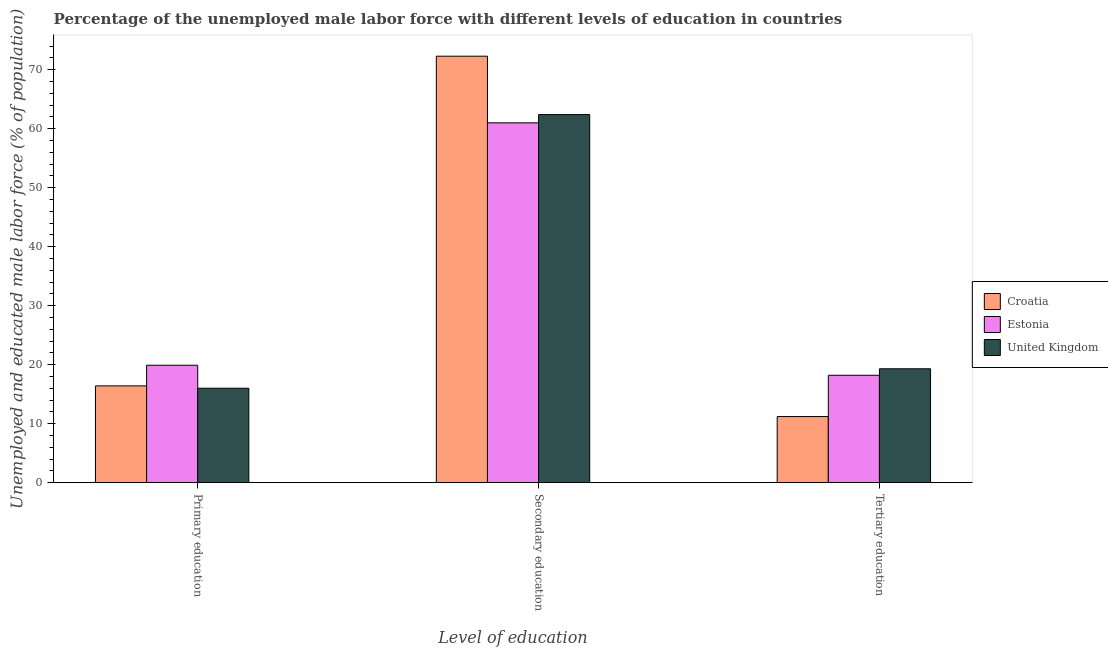How many different coloured bars are there?
Your response must be concise. 3. How many groups of bars are there?
Provide a short and direct response. 3. Are the number of bars per tick equal to the number of legend labels?
Ensure brevity in your answer.  Yes. Are the number of bars on each tick of the X-axis equal?
Give a very brief answer. Yes. How many bars are there on the 2nd tick from the left?
Ensure brevity in your answer.  3. How many bars are there on the 2nd tick from the right?
Keep it short and to the point. 3. What is the label of the 1st group of bars from the left?
Your answer should be compact. Primary education. What is the percentage of male labor force who received tertiary education in Croatia?
Your answer should be compact. 11.2. Across all countries, what is the maximum percentage of male labor force who received secondary education?
Provide a succinct answer. 72.3. In which country was the percentage of male labor force who received tertiary education maximum?
Your answer should be very brief. United Kingdom. In which country was the percentage of male labor force who received tertiary education minimum?
Make the answer very short. Croatia. What is the total percentage of male labor force who received primary education in the graph?
Provide a succinct answer. 52.3. What is the difference between the percentage of male labor force who received primary education in United Kingdom and that in Croatia?
Give a very brief answer. -0.4. What is the difference between the percentage of male labor force who received primary education in United Kingdom and the percentage of male labor force who received secondary education in Croatia?
Your response must be concise. -56.3. What is the average percentage of male labor force who received primary education per country?
Your answer should be compact. 17.43. What is the difference between the percentage of male labor force who received secondary education and percentage of male labor force who received tertiary education in Croatia?
Provide a short and direct response. 61.1. What is the ratio of the percentage of male labor force who received secondary education in Estonia to that in United Kingdom?
Give a very brief answer. 0.98. Is the percentage of male labor force who received secondary education in Estonia less than that in Croatia?
Provide a succinct answer. Yes. Is the difference between the percentage of male labor force who received primary education in Croatia and United Kingdom greater than the difference between the percentage of male labor force who received secondary education in Croatia and United Kingdom?
Keep it short and to the point. No. What is the difference between the highest and the second highest percentage of male labor force who received tertiary education?
Provide a succinct answer. 1.1. What is the difference between the highest and the lowest percentage of male labor force who received primary education?
Give a very brief answer. 3.9. In how many countries, is the percentage of male labor force who received secondary education greater than the average percentage of male labor force who received secondary education taken over all countries?
Keep it short and to the point. 1. What does the 2nd bar from the right in Primary education represents?
Make the answer very short. Estonia. Are all the bars in the graph horizontal?
Your response must be concise. No. How many countries are there in the graph?
Offer a very short reply. 3. What is the difference between two consecutive major ticks on the Y-axis?
Give a very brief answer. 10. Does the graph contain any zero values?
Your response must be concise. No. Does the graph contain grids?
Offer a very short reply. No. Where does the legend appear in the graph?
Give a very brief answer. Center right. How are the legend labels stacked?
Make the answer very short. Vertical. What is the title of the graph?
Give a very brief answer. Percentage of the unemployed male labor force with different levels of education in countries. What is the label or title of the X-axis?
Make the answer very short. Level of education. What is the label or title of the Y-axis?
Make the answer very short. Unemployed and educated male labor force (% of population). What is the Unemployed and educated male labor force (% of population) in Croatia in Primary education?
Provide a short and direct response. 16.4. What is the Unemployed and educated male labor force (% of population) of Estonia in Primary education?
Your answer should be very brief. 19.9. What is the Unemployed and educated male labor force (% of population) of United Kingdom in Primary education?
Your response must be concise. 16. What is the Unemployed and educated male labor force (% of population) in Croatia in Secondary education?
Ensure brevity in your answer.  72.3. What is the Unemployed and educated male labor force (% of population) in United Kingdom in Secondary education?
Ensure brevity in your answer.  62.4. What is the Unemployed and educated male labor force (% of population) in Croatia in Tertiary education?
Make the answer very short. 11.2. What is the Unemployed and educated male labor force (% of population) of Estonia in Tertiary education?
Ensure brevity in your answer.  18.2. What is the Unemployed and educated male labor force (% of population) in United Kingdom in Tertiary education?
Your answer should be compact. 19.3. Across all Level of education, what is the maximum Unemployed and educated male labor force (% of population) of Croatia?
Ensure brevity in your answer.  72.3. Across all Level of education, what is the maximum Unemployed and educated male labor force (% of population) of Estonia?
Provide a succinct answer. 61. Across all Level of education, what is the maximum Unemployed and educated male labor force (% of population) in United Kingdom?
Make the answer very short. 62.4. Across all Level of education, what is the minimum Unemployed and educated male labor force (% of population) in Croatia?
Offer a very short reply. 11.2. Across all Level of education, what is the minimum Unemployed and educated male labor force (% of population) of Estonia?
Offer a terse response. 18.2. What is the total Unemployed and educated male labor force (% of population) of Croatia in the graph?
Ensure brevity in your answer.  99.9. What is the total Unemployed and educated male labor force (% of population) in Estonia in the graph?
Offer a terse response. 99.1. What is the total Unemployed and educated male labor force (% of population) of United Kingdom in the graph?
Offer a very short reply. 97.7. What is the difference between the Unemployed and educated male labor force (% of population) in Croatia in Primary education and that in Secondary education?
Your response must be concise. -55.9. What is the difference between the Unemployed and educated male labor force (% of population) in Estonia in Primary education and that in Secondary education?
Ensure brevity in your answer.  -41.1. What is the difference between the Unemployed and educated male labor force (% of population) of United Kingdom in Primary education and that in Secondary education?
Provide a succinct answer. -46.4. What is the difference between the Unemployed and educated male labor force (% of population) of Croatia in Primary education and that in Tertiary education?
Provide a succinct answer. 5.2. What is the difference between the Unemployed and educated male labor force (% of population) in Croatia in Secondary education and that in Tertiary education?
Keep it short and to the point. 61.1. What is the difference between the Unemployed and educated male labor force (% of population) of Estonia in Secondary education and that in Tertiary education?
Your answer should be very brief. 42.8. What is the difference between the Unemployed and educated male labor force (% of population) in United Kingdom in Secondary education and that in Tertiary education?
Provide a succinct answer. 43.1. What is the difference between the Unemployed and educated male labor force (% of population) in Croatia in Primary education and the Unemployed and educated male labor force (% of population) in Estonia in Secondary education?
Offer a terse response. -44.6. What is the difference between the Unemployed and educated male labor force (% of population) of Croatia in Primary education and the Unemployed and educated male labor force (% of population) of United Kingdom in Secondary education?
Make the answer very short. -46. What is the difference between the Unemployed and educated male labor force (% of population) in Estonia in Primary education and the Unemployed and educated male labor force (% of population) in United Kingdom in Secondary education?
Provide a short and direct response. -42.5. What is the difference between the Unemployed and educated male labor force (% of population) of Croatia in Primary education and the Unemployed and educated male labor force (% of population) of Estonia in Tertiary education?
Provide a short and direct response. -1.8. What is the difference between the Unemployed and educated male labor force (% of population) of Estonia in Primary education and the Unemployed and educated male labor force (% of population) of United Kingdom in Tertiary education?
Your answer should be compact. 0.6. What is the difference between the Unemployed and educated male labor force (% of population) in Croatia in Secondary education and the Unemployed and educated male labor force (% of population) in Estonia in Tertiary education?
Provide a short and direct response. 54.1. What is the difference between the Unemployed and educated male labor force (% of population) of Croatia in Secondary education and the Unemployed and educated male labor force (% of population) of United Kingdom in Tertiary education?
Your answer should be very brief. 53. What is the difference between the Unemployed and educated male labor force (% of population) in Estonia in Secondary education and the Unemployed and educated male labor force (% of population) in United Kingdom in Tertiary education?
Offer a very short reply. 41.7. What is the average Unemployed and educated male labor force (% of population) in Croatia per Level of education?
Your response must be concise. 33.3. What is the average Unemployed and educated male labor force (% of population) of Estonia per Level of education?
Ensure brevity in your answer.  33.03. What is the average Unemployed and educated male labor force (% of population) in United Kingdom per Level of education?
Keep it short and to the point. 32.57. What is the difference between the Unemployed and educated male labor force (% of population) of Croatia and Unemployed and educated male labor force (% of population) of Estonia in Primary education?
Give a very brief answer. -3.5. What is the difference between the Unemployed and educated male labor force (% of population) in Croatia and Unemployed and educated male labor force (% of population) in United Kingdom in Primary education?
Your answer should be very brief. 0.4. What is the difference between the Unemployed and educated male labor force (% of population) of Estonia and Unemployed and educated male labor force (% of population) of United Kingdom in Primary education?
Offer a terse response. 3.9. What is the difference between the Unemployed and educated male labor force (% of population) of Croatia and Unemployed and educated male labor force (% of population) of United Kingdom in Secondary education?
Keep it short and to the point. 9.9. What is the ratio of the Unemployed and educated male labor force (% of population) in Croatia in Primary education to that in Secondary education?
Give a very brief answer. 0.23. What is the ratio of the Unemployed and educated male labor force (% of population) in Estonia in Primary education to that in Secondary education?
Provide a short and direct response. 0.33. What is the ratio of the Unemployed and educated male labor force (% of population) in United Kingdom in Primary education to that in Secondary education?
Offer a very short reply. 0.26. What is the ratio of the Unemployed and educated male labor force (% of population) of Croatia in Primary education to that in Tertiary education?
Your response must be concise. 1.46. What is the ratio of the Unemployed and educated male labor force (% of population) in Estonia in Primary education to that in Tertiary education?
Give a very brief answer. 1.09. What is the ratio of the Unemployed and educated male labor force (% of population) in United Kingdom in Primary education to that in Tertiary education?
Make the answer very short. 0.83. What is the ratio of the Unemployed and educated male labor force (% of population) in Croatia in Secondary education to that in Tertiary education?
Offer a terse response. 6.46. What is the ratio of the Unemployed and educated male labor force (% of population) of Estonia in Secondary education to that in Tertiary education?
Ensure brevity in your answer.  3.35. What is the ratio of the Unemployed and educated male labor force (% of population) of United Kingdom in Secondary education to that in Tertiary education?
Your response must be concise. 3.23. What is the difference between the highest and the second highest Unemployed and educated male labor force (% of population) of Croatia?
Give a very brief answer. 55.9. What is the difference between the highest and the second highest Unemployed and educated male labor force (% of population) of Estonia?
Give a very brief answer. 41.1. What is the difference between the highest and the second highest Unemployed and educated male labor force (% of population) of United Kingdom?
Ensure brevity in your answer.  43.1. What is the difference between the highest and the lowest Unemployed and educated male labor force (% of population) in Croatia?
Ensure brevity in your answer.  61.1. What is the difference between the highest and the lowest Unemployed and educated male labor force (% of population) in Estonia?
Your answer should be very brief. 42.8. What is the difference between the highest and the lowest Unemployed and educated male labor force (% of population) in United Kingdom?
Your response must be concise. 46.4. 